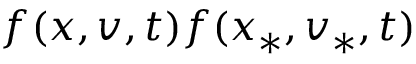Convert formula to latex. <formula><loc_0><loc_0><loc_500><loc_500>f ( x , v , t ) f ( x _ { \ast } , v _ { \ast } , t )</formula> 